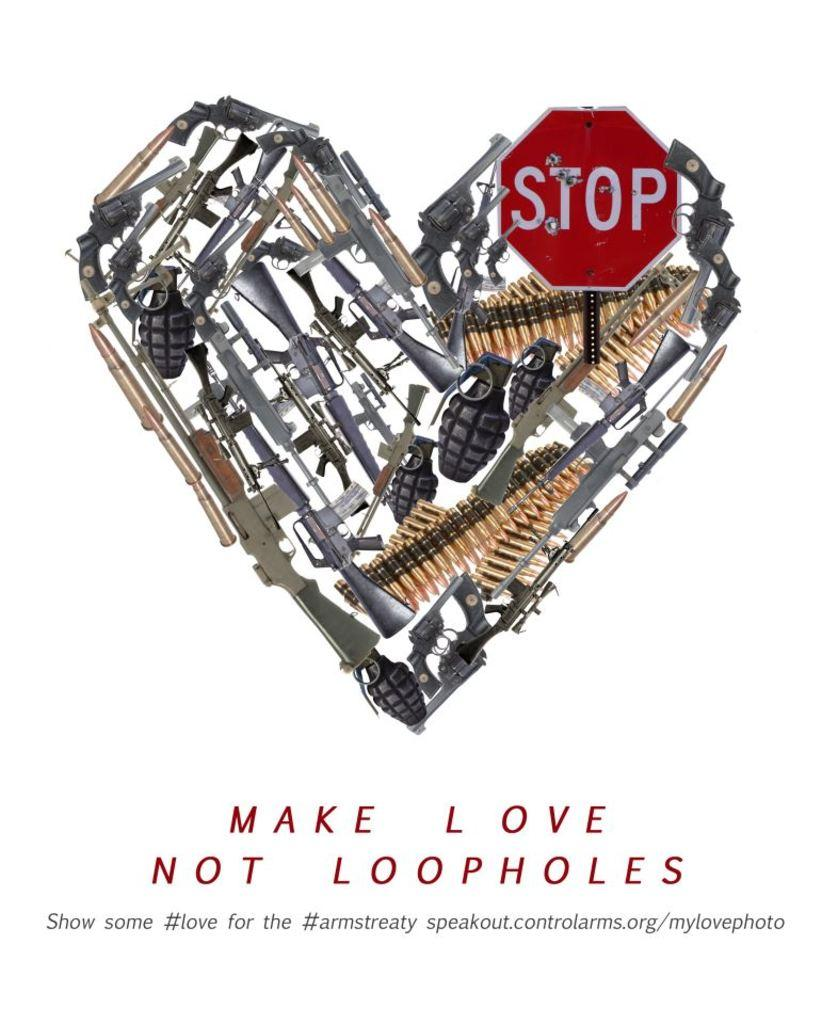<image>
Describe the image concisely. A heart is made out of weapons and a stop sign with the caption Make Love Not Loopholes. 